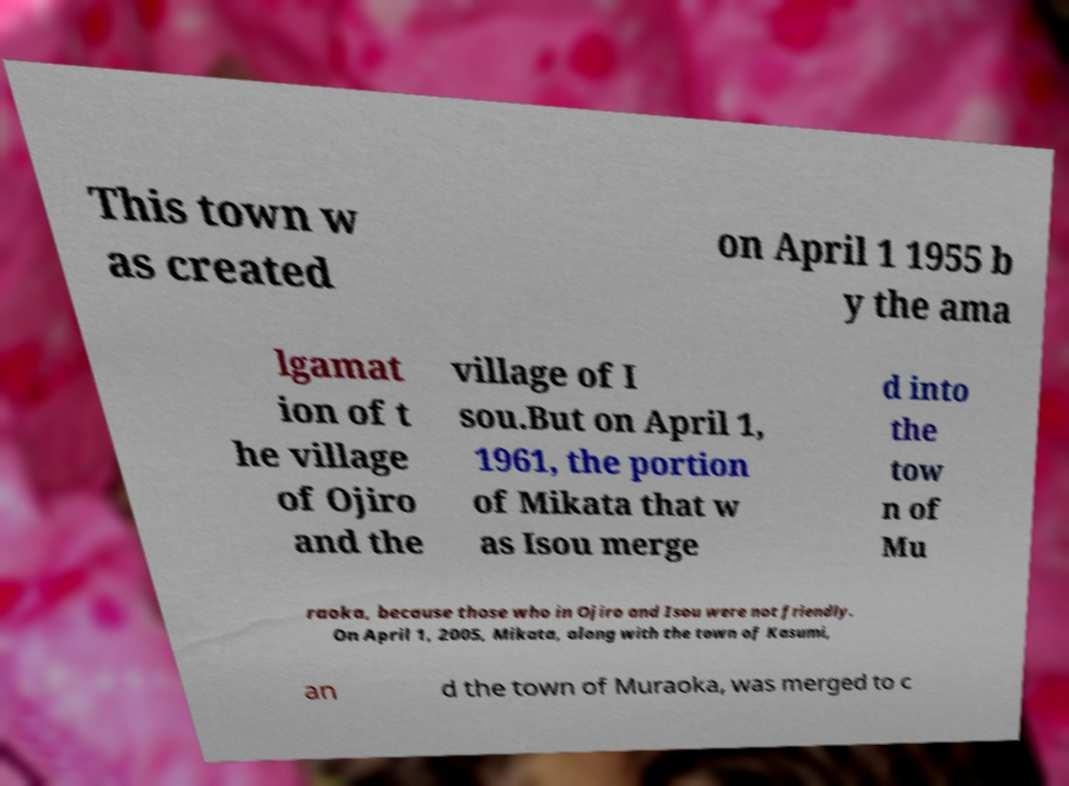What messages or text are displayed in this image? I need them in a readable, typed format. This town w as created on April 1 1955 b y the ama lgamat ion of t he village of Ojiro and the village of I sou.But on April 1, 1961, the portion of Mikata that w as Isou merge d into the tow n of Mu raoka, because those who in Ojiro and Isou were not friendly. On April 1, 2005, Mikata, along with the town of Kasumi, an d the town of Muraoka, was merged to c 